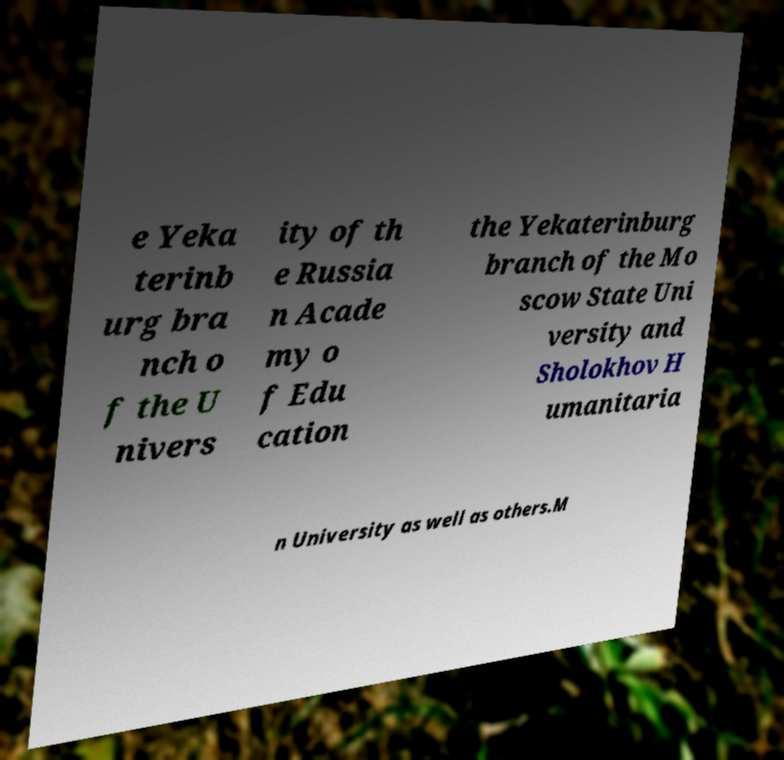Can you accurately transcribe the text from the provided image for me? e Yeka terinb urg bra nch o f the U nivers ity of th e Russia n Acade my o f Edu cation the Yekaterinburg branch of the Mo scow State Uni versity and Sholokhov H umanitaria n University as well as others.M 